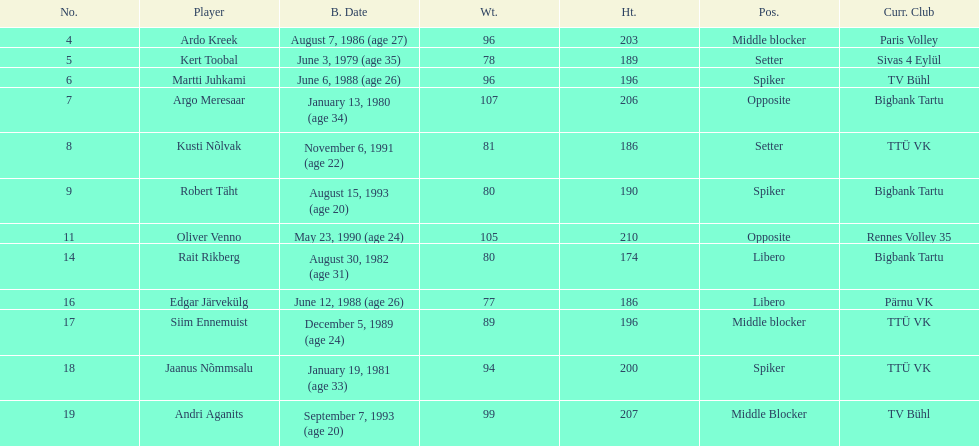How many members of estonia's men's national volleyball team were born in 1988? 2. 